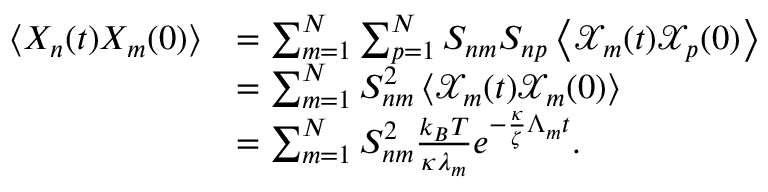<formula> <loc_0><loc_0><loc_500><loc_500>\begin{array} { r l } { \left < X _ { n } ( t ) X _ { m } ( 0 ) \right > } & { = \sum _ { m = 1 } ^ { N } \sum _ { p = 1 } ^ { N } S _ { n m } S _ { n p } \left < \mathcal { X } _ { m } ( t ) \mathcal { X } _ { p } ( 0 ) \right > } \\ & { = \sum _ { m = 1 } ^ { N } S _ { n m } ^ { 2 } \left < \mathcal { X } _ { m } ( t ) \mathcal { X } _ { m } ( 0 ) \right > } \\ & { = \sum _ { m = 1 } ^ { N } S _ { n m } ^ { 2 } \frac { k _ { B } T } { \kappa \lambda _ { m } } e ^ { - \frac { \kappa } { \zeta } \Lambda _ { m } t } . } \end{array}</formula> 